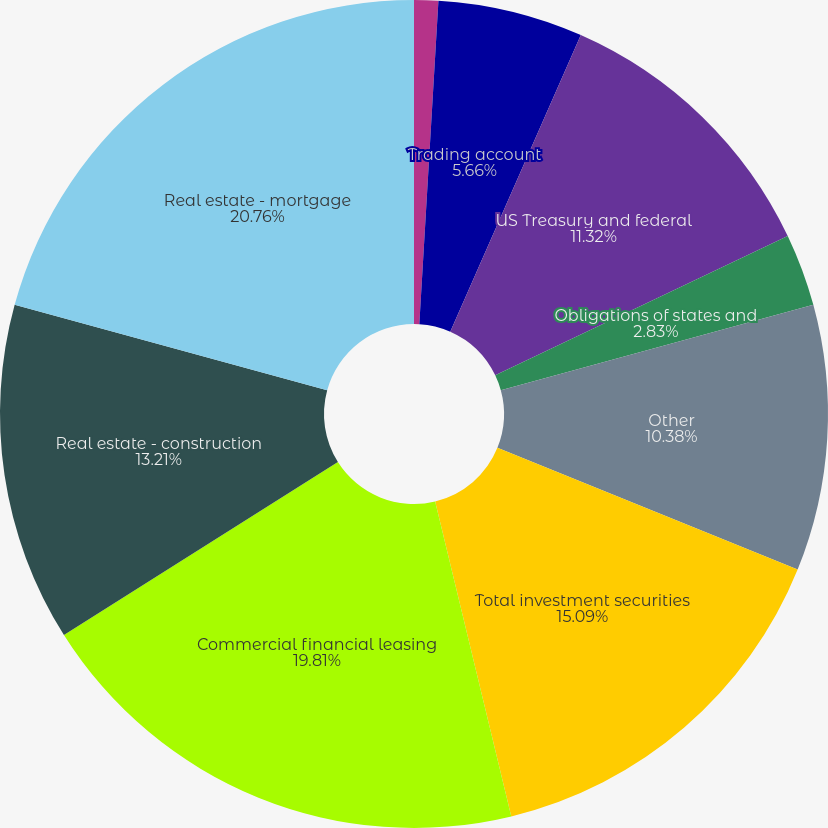Convert chart. <chart><loc_0><loc_0><loc_500><loc_500><pie_chart><fcel>Interest-bearing deposits at<fcel>Federal funds sold<fcel>Trading account<fcel>US Treasury and federal<fcel>Obligations of states and<fcel>Other<fcel>Total investment securities<fcel>Commercial financial leasing<fcel>Real estate - construction<fcel>Real estate - mortgage<nl><fcel>0.0%<fcel>0.94%<fcel>5.66%<fcel>11.32%<fcel>2.83%<fcel>10.38%<fcel>15.09%<fcel>19.81%<fcel>13.21%<fcel>20.75%<nl></chart> 